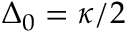<formula> <loc_0><loc_0><loc_500><loc_500>\Delta _ { 0 } = { \kappa } / { 2 }</formula> 